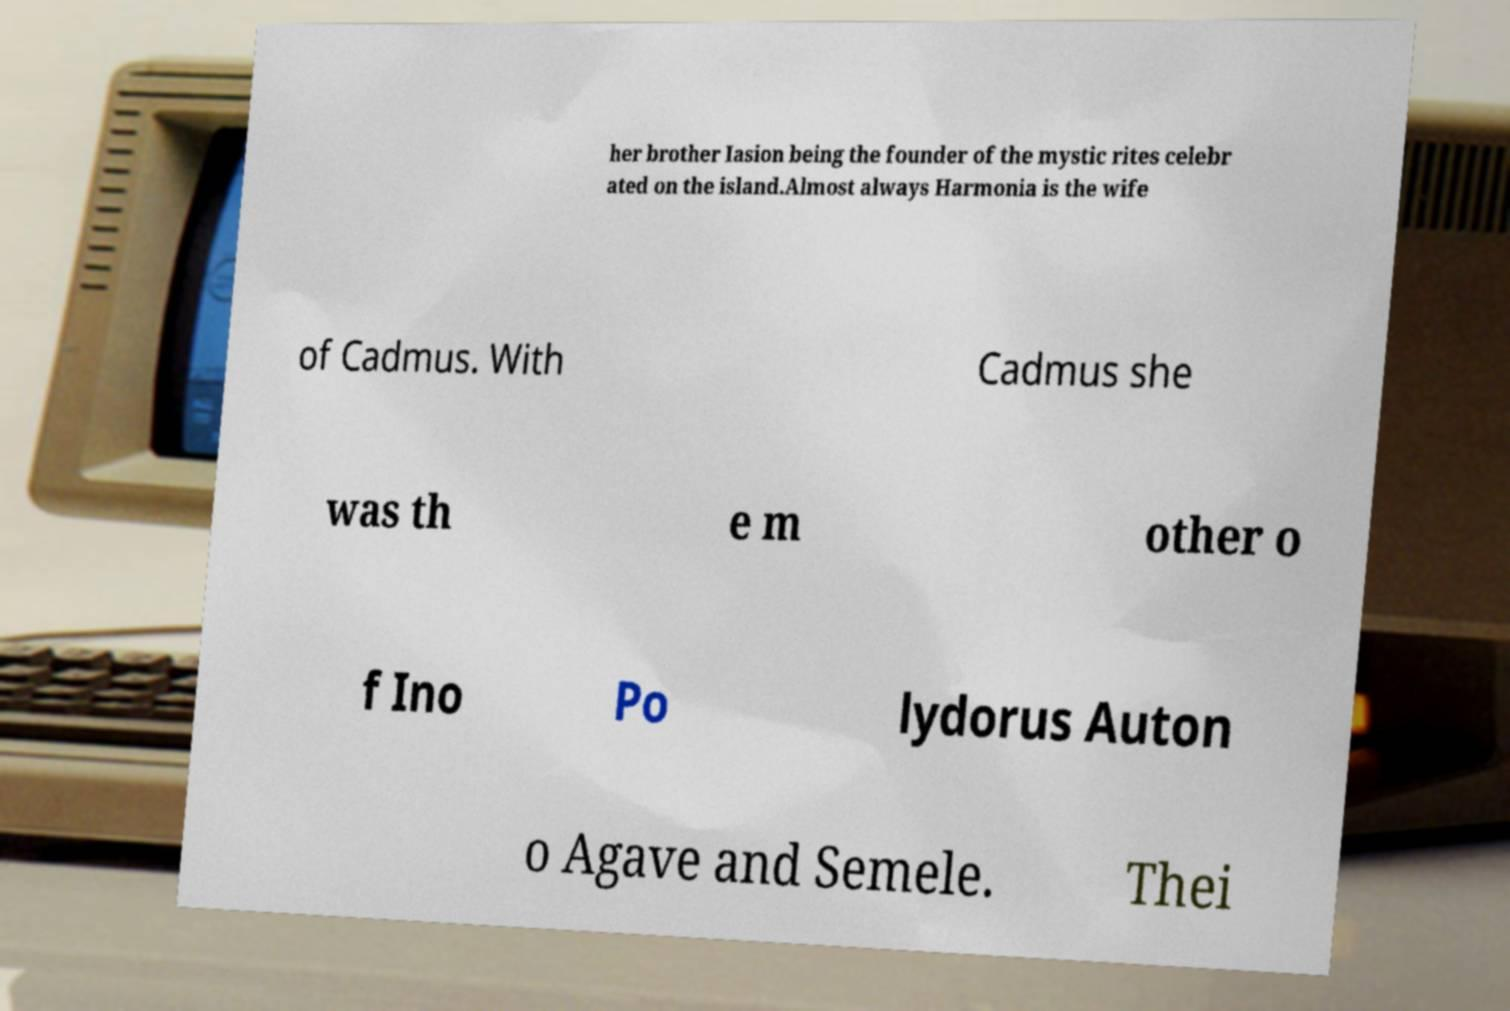For documentation purposes, I need the text within this image transcribed. Could you provide that? her brother Iasion being the founder of the mystic rites celebr ated on the island.Almost always Harmonia is the wife of Cadmus. With Cadmus she was th e m other o f Ino Po lydorus Auton o Agave and Semele. Thei 